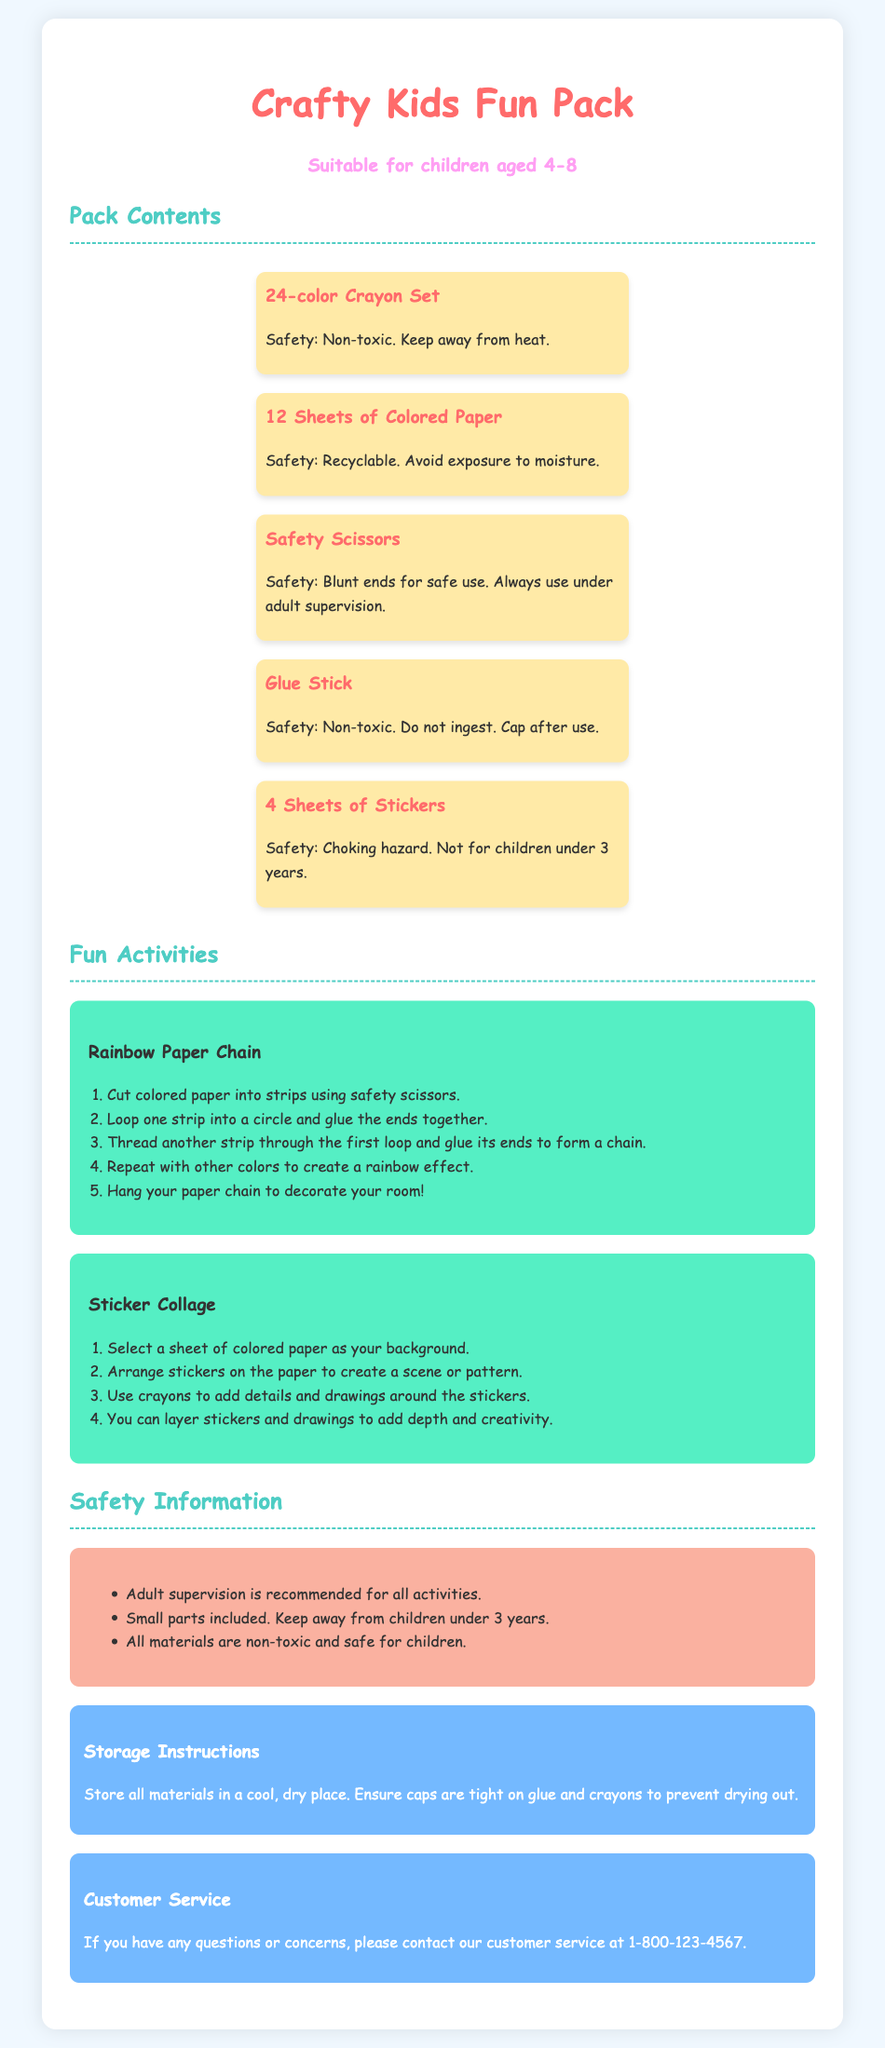What is the age range for this craft kit? The age range listed in the document specifies that it is suitable for children aged 4-8.
Answer: 4-8 How many crayons are included in the set? The document states that there is a 24-color crayon set included in the pack.
Answer: 24 What type of scissors are provided? The document specifies that safety scissors with blunt ends are provided in the pack.
Answer: Safety scissors What decoration project involves cutting colored paper? The "Rainbow Paper Chain" activity involves cutting colored paper into strips.
Answer: Rainbow Paper Chain What safety warning is given for small parts? The document warns that small parts are included and should be kept away from children under 3 years.
Answer: Small parts warning What do you need to create the sticker collage? The sticker collage activity requires selecting a sheet of colored paper as the background and arranging stickers on it.
Answer: Colored paper and stickers What should you ensure about the glue and crayons to prevent them from drying out? The storage instructions mention that caps should be tight on glue and crayons to prevent drying out.
Answer: Ensure caps are tight What contact number is provided for customer service? The document lists the customer service number for inquiries as 1-800-123-4567.
Answer: 1-800-123-4567 